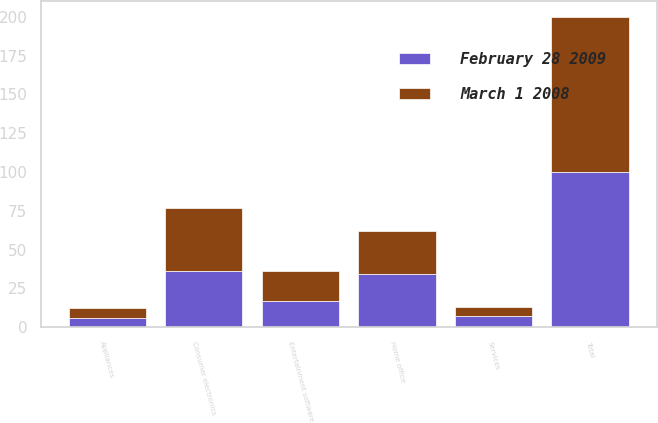Convert chart. <chart><loc_0><loc_0><loc_500><loc_500><stacked_bar_chart><ecel><fcel>Consumer electronics<fcel>Home office<fcel>Entertainment software<fcel>Appliances<fcel>Services<fcel>Total<nl><fcel>February 28 2009<fcel>36<fcel>34<fcel>17<fcel>6<fcel>7<fcel>100<nl><fcel>March 1 2008<fcel>41<fcel>28<fcel>19<fcel>6<fcel>6<fcel>100<nl></chart> 